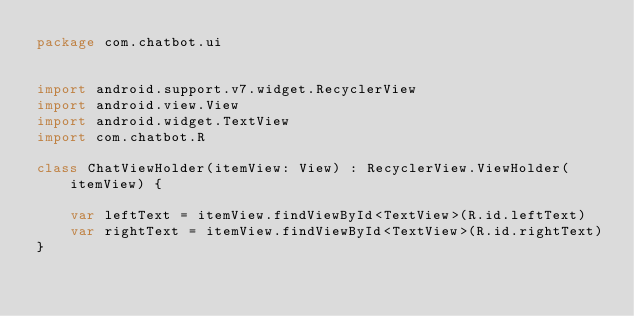<code> <loc_0><loc_0><loc_500><loc_500><_Kotlin_>package com.chatbot.ui


import android.support.v7.widget.RecyclerView
import android.view.View
import android.widget.TextView
import com.chatbot.R

class ChatViewHolder(itemView: View) : RecyclerView.ViewHolder(itemView) {

    var leftText = itemView.findViewById<TextView>(R.id.leftText)
    var rightText = itemView.findViewById<TextView>(R.id.rightText)
}
</code> 